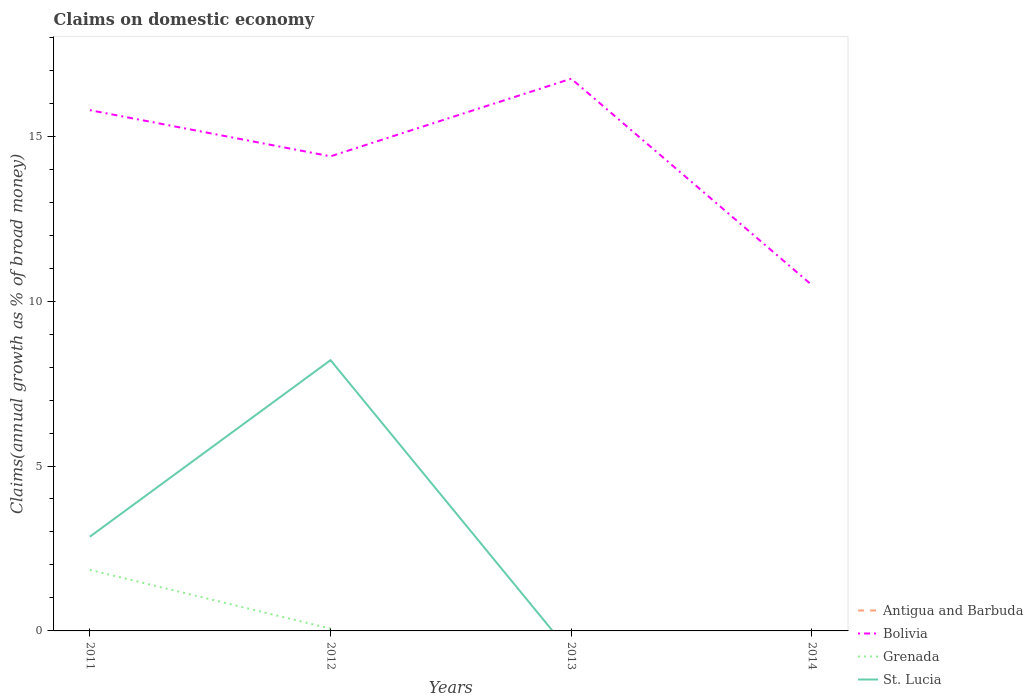How many different coloured lines are there?
Offer a very short reply. 3. Does the line corresponding to Bolivia intersect with the line corresponding to St. Lucia?
Ensure brevity in your answer.  No. Across all years, what is the maximum percentage of broad money claimed on domestic economy in Bolivia?
Your answer should be compact. 10.48. What is the total percentage of broad money claimed on domestic economy in Bolivia in the graph?
Make the answer very short. -2.35. What is the difference between the highest and the second highest percentage of broad money claimed on domestic economy in Grenada?
Offer a very short reply. 1.85. How many lines are there?
Offer a very short reply. 3. How many years are there in the graph?
Your answer should be compact. 4. Are the values on the major ticks of Y-axis written in scientific E-notation?
Make the answer very short. No. Does the graph contain any zero values?
Your answer should be very brief. Yes. Does the graph contain grids?
Give a very brief answer. No. How are the legend labels stacked?
Your response must be concise. Vertical. What is the title of the graph?
Offer a very short reply. Claims on domestic economy. Does "Togo" appear as one of the legend labels in the graph?
Ensure brevity in your answer.  No. What is the label or title of the X-axis?
Your response must be concise. Years. What is the label or title of the Y-axis?
Offer a very short reply. Claims(annual growth as % of broad money). What is the Claims(annual growth as % of broad money) in Antigua and Barbuda in 2011?
Your answer should be compact. 0. What is the Claims(annual growth as % of broad money) in Bolivia in 2011?
Your response must be concise. 15.79. What is the Claims(annual growth as % of broad money) of Grenada in 2011?
Keep it short and to the point. 1.85. What is the Claims(annual growth as % of broad money) of St. Lucia in 2011?
Your response must be concise. 2.86. What is the Claims(annual growth as % of broad money) of Antigua and Barbuda in 2012?
Ensure brevity in your answer.  0. What is the Claims(annual growth as % of broad money) in Bolivia in 2012?
Give a very brief answer. 14.39. What is the Claims(annual growth as % of broad money) of Grenada in 2012?
Keep it short and to the point. 0.07. What is the Claims(annual growth as % of broad money) in St. Lucia in 2012?
Keep it short and to the point. 8.21. What is the Claims(annual growth as % of broad money) of Bolivia in 2013?
Ensure brevity in your answer.  16.74. What is the Claims(annual growth as % of broad money) in Grenada in 2013?
Offer a terse response. 0. What is the Claims(annual growth as % of broad money) of Antigua and Barbuda in 2014?
Keep it short and to the point. 0. What is the Claims(annual growth as % of broad money) of Bolivia in 2014?
Provide a succinct answer. 10.48. What is the Claims(annual growth as % of broad money) in Grenada in 2014?
Offer a very short reply. 0. What is the Claims(annual growth as % of broad money) of St. Lucia in 2014?
Provide a succinct answer. 0. Across all years, what is the maximum Claims(annual growth as % of broad money) in Bolivia?
Your response must be concise. 16.74. Across all years, what is the maximum Claims(annual growth as % of broad money) in Grenada?
Your response must be concise. 1.85. Across all years, what is the maximum Claims(annual growth as % of broad money) in St. Lucia?
Give a very brief answer. 8.21. Across all years, what is the minimum Claims(annual growth as % of broad money) of Bolivia?
Offer a terse response. 10.48. What is the total Claims(annual growth as % of broad money) in Antigua and Barbuda in the graph?
Ensure brevity in your answer.  0. What is the total Claims(annual growth as % of broad money) in Bolivia in the graph?
Offer a very short reply. 57.4. What is the total Claims(annual growth as % of broad money) in Grenada in the graph?
Offer a terse response. 1.92. What is the total Claims(annual growth as % of broad money) of St. Lucia in the graph?
Offer a terse response. 11.06. What is the difference between the Claims(annual growth as % of broad money) in Bolivia in 2011 and that in 2012?
Ensure brevity in your answer.  1.4. What is the difference between the Claims(annual growth as % of broad money) in Grenada in 2011 and that in 2012?
Keep it short and to the point. 1.78. What is the difference between the Claims(annual growth as % of broad money) in St. Lucia in 2011 and that in 2012?
Your response must be concise. -5.35. What is the difference between the Claims(annual growth as % of broad money) of Bolivia in 2011 and that in 2013?
Keep it short and to the point. -0.95. What is the difference between the Claims(annual growth as % of broad money) in Bolivia in 2011 and that in 2014?
Make the answer very short. 5.31. What is the difference between the Claims(annual growth as % of broad money) in Bolivia in 2012 and that in 2013?
Make the answer very short. -2.35. What is the difference between the Claims(annual growth as % of broad money) of Bolivia in 2012 and that in 2014?
Your response must be concise. 3.91. What is the difference between the Claims(annual growth as % of broad money) in Bolivia in 2013 and that in 2014?
Provide a short and direct response. 6.26. What is the difference between the Claims(annual growth as % of broad money) of Bolivia in 2011 and the Claims(annual growth as % of broad money) of Grenada in 2012?
Give a very brief answer. 15.72. What is the difference between the Claims(annual growth as % of broad money) in Bolivia in 2011 and the Claims(annual growth as % of broad money) in St. Lucia in 2012?
Give a very brief answer. 7.58. What is the difference between the Claims(annual growth as % of broad money) in Grenada in 2011 and the Claims(annual growth as % of broad money) in St. Lucia in 2012?
Offer a terse response. -6.36. What is the average Claims(annual growth as % of broad money) of Antigua and Barbuda per year?
Your answer should be compact. 0. What is the average Claims(annual growth as % of broad money) in Bolivia per year?
Offer a very short reply. 14.35. What is the average Claims(annual growth as % of broad money) of Grenada per year?
Your answer should be very brief. 0.48. What is the average Claims(annual growth as % of broad money) of St. Lucia per year?
Ensure brevity in your answer.  2.77. In the year 2011, what is the difference between the Claims(annual growth as % of broad money) of Bolivia and Claims(annual growth as % of broad money) of Grenada?
Ensure brevity in your answer.  13.94. In the year 2011, what is the difference between the Claims(annual growth as % of broad money) of Bolivia and Claims(annual growth as % of broad money) of St. Lucia?
Offer a terse response. 12.93. In the year 2011, what is the difference between the Claims(annual growth as % of broad money) of Grenada and Claims(annual growth as % of broad money) of St. Lucia?
Offer a very short reply. -1. In the year 2012, what is the difference between the Claims(annual growth as % of broad money) of Bolivia and Claims(annual growth as % of broad money) of Grenada?
Ensure brevity in your answer.  14.32. In the year 2012, what is the difference between the Claims(annual growth as % of broad money) of Bolivia and Claims(annual growth as % of broad money) of St. Lucia?
Your response must be concise. 6.18. In the year 2012, what is the difference between the Claims(annual growth as % of broad money) of Grenada and Claims(annual growth as % of broad money) of St. Lucia?
Provide a succinct answer. -8.14. What is the ratio of the Claims(annual growth as % of broad money) in Bolivia in 2011 to that in 2012?
Give a very brief answer. 1.1. What is the ratio of the Claims(annual growth as % of broad money) of Grenada in 2011 to that in 2012?
Offer a terse response. 26.77. What is the ratio of the Claims(annual growth as % of broad money) in St. Lucia in 2011 to that in 2012?
Offer a terse response. 0.35. What is the ratio of the Claims(annual growth as % of broad money) in Bolivia in 2011 to that in 2013?
Make the answer very short. 0.94. What is the ratio of the Claims(annual growth as % of broad money) of Bolivia in 2011 to that in 2014?
Keep it short and to the point. 1.51. What is the ratio of the Claims(annual growth as % of broad money) of Bolivia in 2012 to that in 2013?
Give a very brief answer. 0.86. What is the ratio of the Claims(annual growth as % of broad money) in Bolivia in 2012 to that in 2014?
Offer a very short reply. 1.37. What is the ratio of the Claims(annual growth as % of broad money) of Bolivia in 2013 to that in 2014?
Ensure brevity in your answer.  1.6. What is the difference between the highest and the second highest Claims(annual growth as % of broad money) of Bolivia?
Ensure brevity in your answer.  0.95. What is the difference between the highest and the lowest Claims(annual growth as % of broad money) of Bolivia?
Your answer should be very brief. 6.26. What is the difference between the highest and the lowest Claims(annual growth as % of broad money) in Grenada?
Your answer should be very brief. 1.85. What is the difference between the highest and the lowest Claims(annual growth as % of broad money) in St. Lucia?
Offer a terse response. 8.21. 